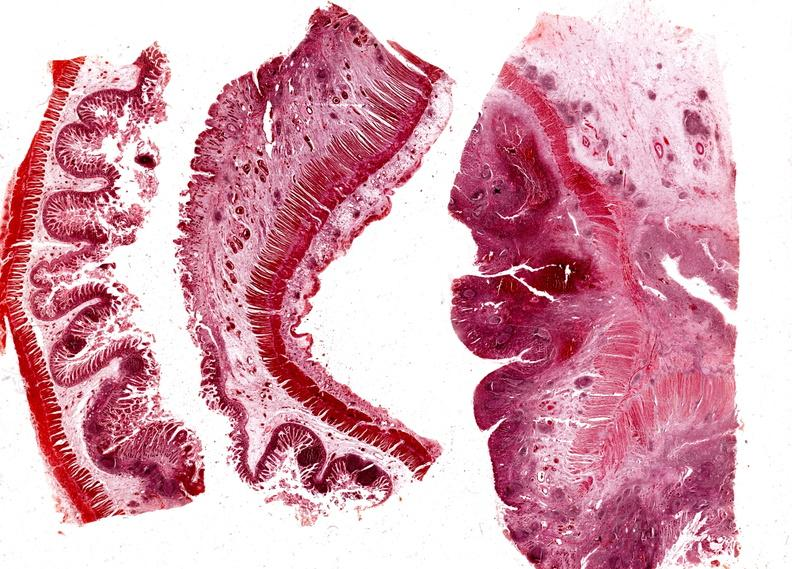where is this from?
Answer the question using a single word or phrase. Gastrointestinal system 